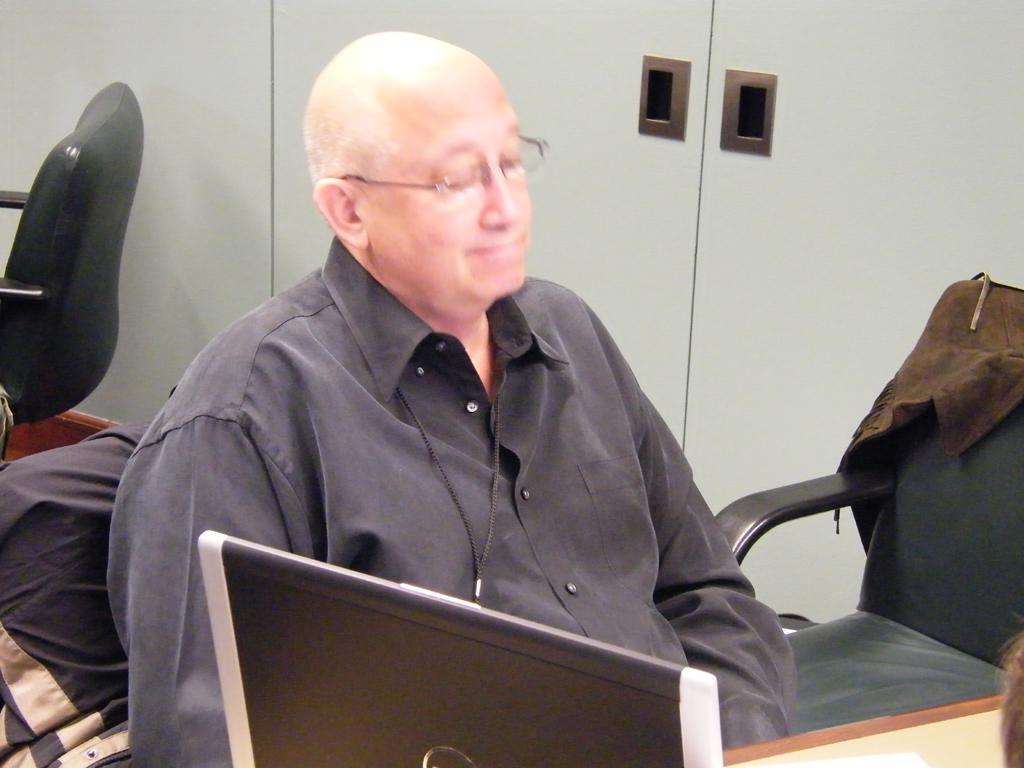Describe this image in one or two sentences. A man is siting in the middle wearing a black shirt. He is wearing glasses. In the right side there is a chair on it a jacket is hanged. On the left side there is another chair. In the background there are cupboard. In the foreground there are laptops. 